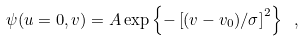Convert formula to latex. <formula><loc_0><loc_0><loc_500><loc_500>\psi ( u = 0 , v ) = A \exp \left \{ - \left [ ( v - v _ { 0 } ) / \sigma \right ] ^ { 2 } \right \} \ ,</formula> 